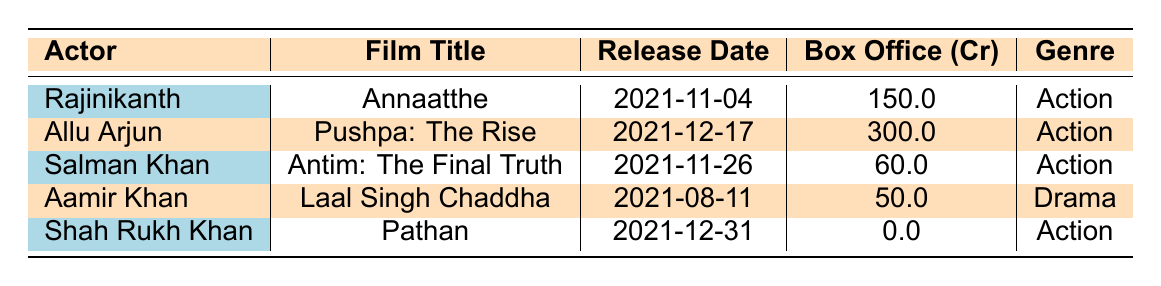What is the title of the film released by Rajinikanth? The table shows that Rajinikanth has one film listed, which is titled "Annaatthe".
Answer: Annaatthe Which actor's film had the highest box office collection? By comparing the box office collections from each row, Allu Arjun's "Pushpa: The Rise" has the highest collection of 300.0 crores.
Answer: Allu Arjun Did Shah Rukh Khan release a film in 2021 that earned box office revenue? The table indicates that Shah Rukh Khan's film "Pathan" has a box office revenue of 0.0 crores, which confirms it did not earn any revenue.
Answer: No How many films were released in November 2021? The table lists two films released in November: "Annaatthe" on 2021-11-04 and "Antim: The Final Truth" on 2021-11-26, making two films in total.
Answer: 2 What is the total box office collection from all films listed in the table? The box office revenue can be summed: 150.0 + 300.0 + 60.0 + 50.0 + 0.0 = 560.0 crores. Therefore, the total collection is 560.0 crores.
Answer: 560.0 Which actor belongs to the Drama genre? Upon examining the table, Aamir Khan's film "Laal Singh Chaddha" is the only one classified under the Drama genre.
Answer: Aamir Khan Was there a film released by Salman Khan in December 2021? Searching through the table reveals that Salman Khan's film "Antim: The Final Truth" was released in November, not December.
Answer: No Which actor has released films in both November and December? From the table, Allu Arjun's film was released in December, and Rajinikanth and Salman Khan had releases in November, but no single actor is listed with both, confirming none fits this criterion.
Answer: None 